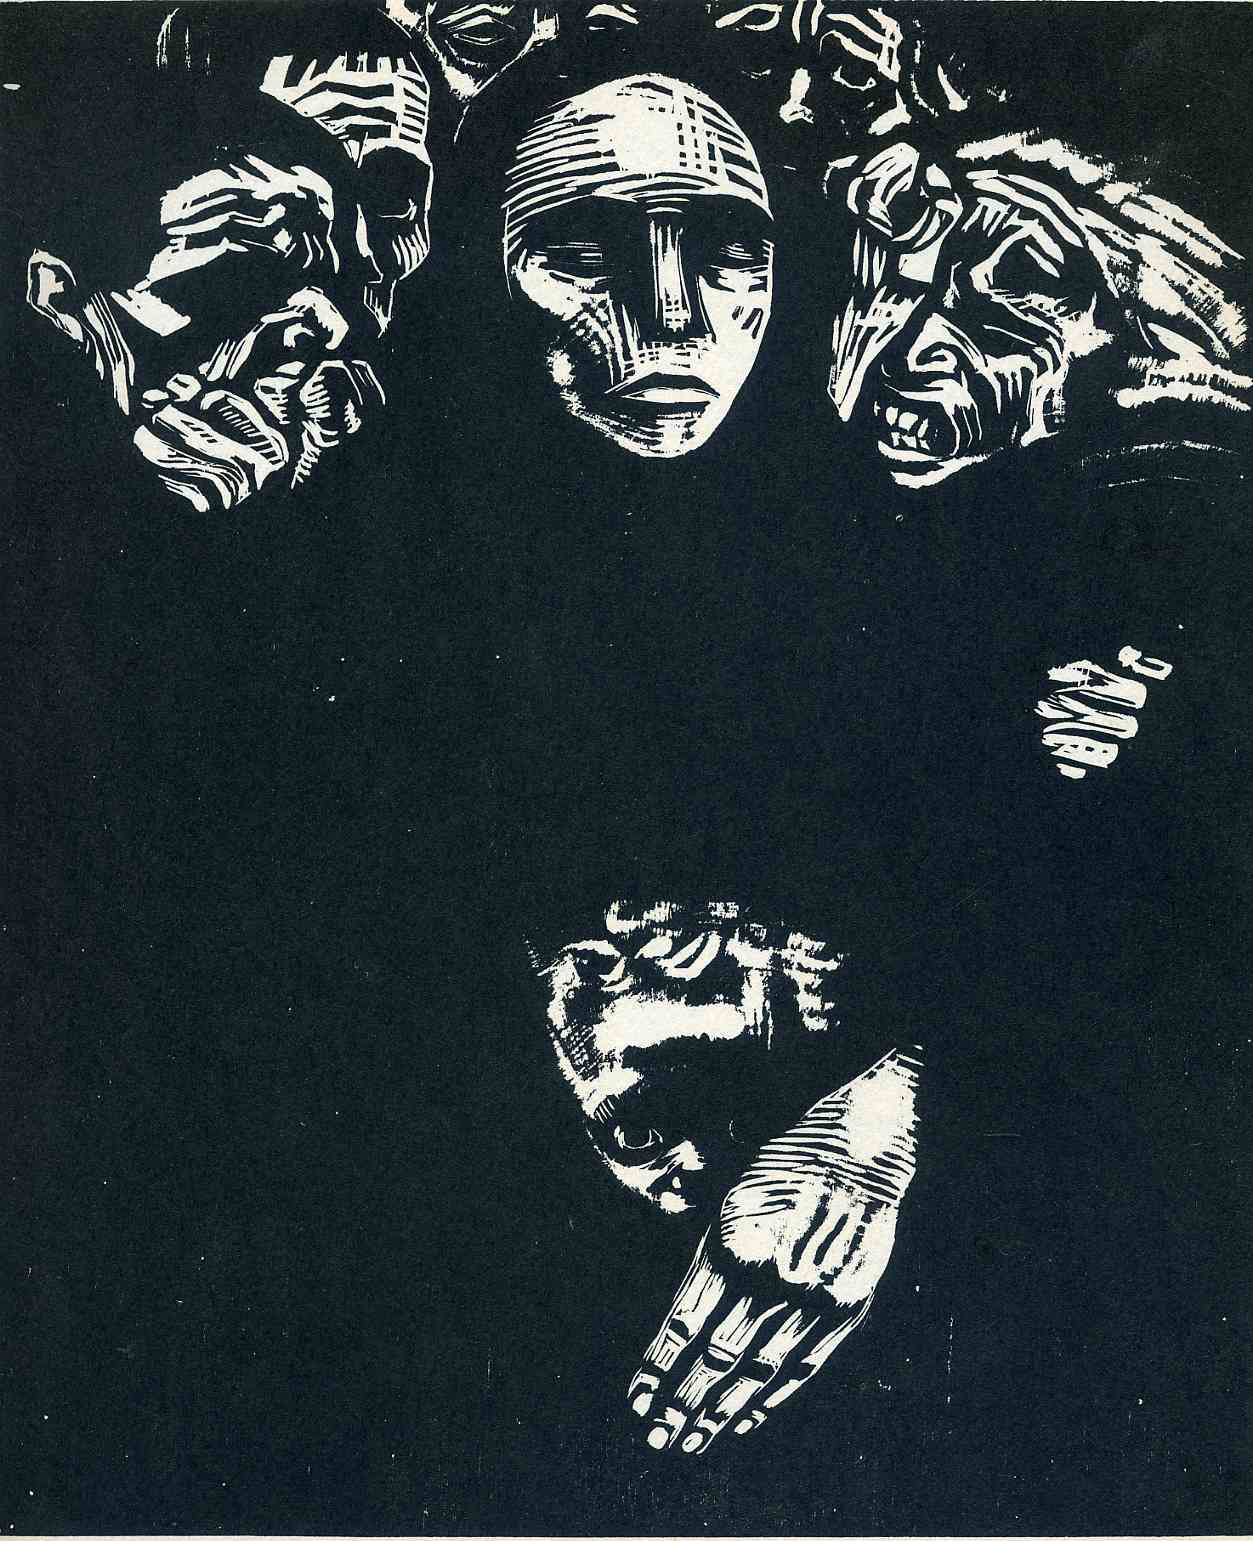What emotions do you think the artist was trying to convey through the use of contrasting elements in this artwork? The stark contrast in the artwork likely aims to evoke a sense of inner conflict or turmoil. The use of black and white intensifies the dramatic interaction between the faces and hands, possibly depicting the stark differences between what is shown to the world and what is felt internally. It might also represent existential themes, contrasting the clarity and obscurity we experience in life and consciousness. 